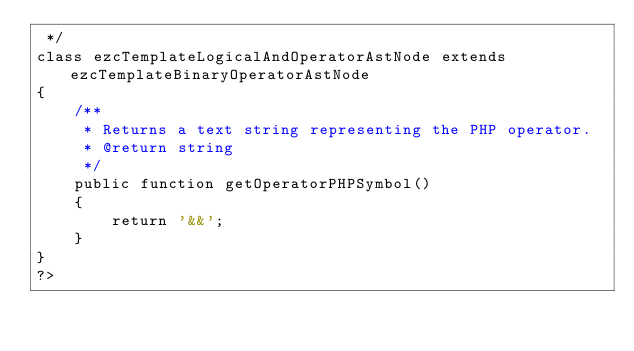<code> <loc_0><loc_0><loc_500><loc_500><_PHP_> */
class ezcTemplateLogicalAndOperatorAstNode extends ezcTemplateBinaryOperatorAstNode
{
    /**
     * Returns a text string representing the PHP operator.
     * @return string
     */
    public function getOperatorPHPSymbol()
    {
        return '&&';
    }
}
?>
</code> 